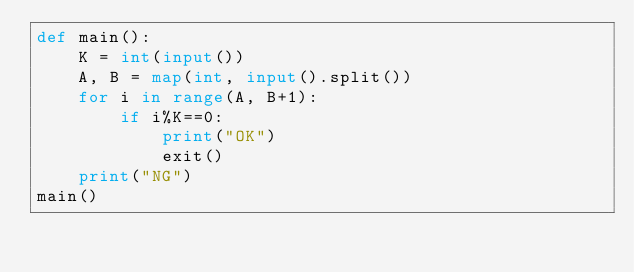<code> <loc_0><loc_0><loc_500><loc_500><_Python_>def main():
    K = int(input())
    A, B = map(int, input().split())
    for i in range(A, B+1):
        if i%K==0:
            print("OK")
            exit()
    print("NG")
main()</code> 